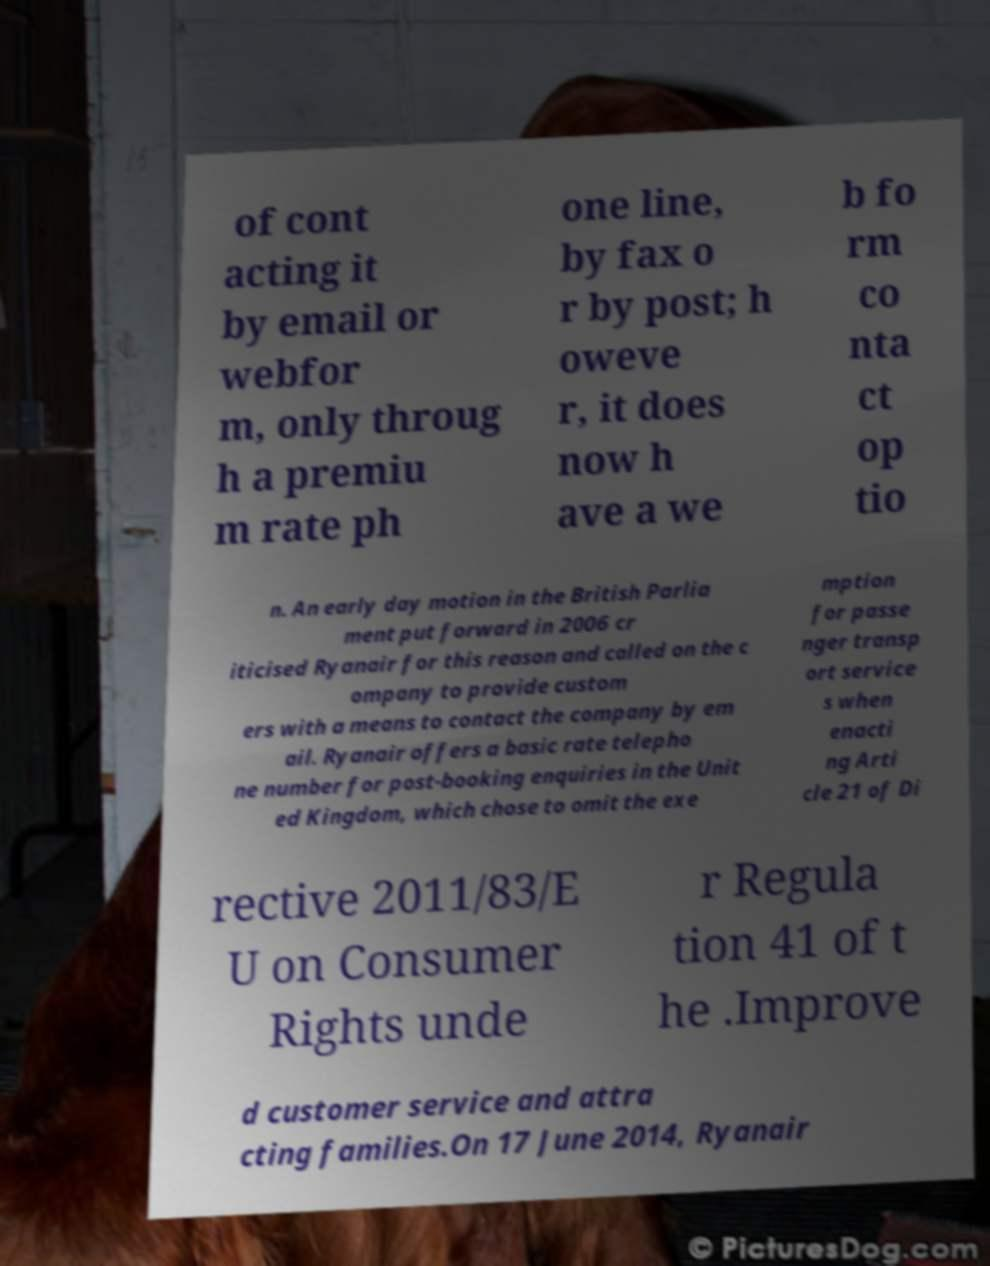There's text embedded in this image that I need extracted. Can you transcribe it verbatim? of cont acting it by email or webfor m, only throug h a premiu m rate ph one line, by fax o r by post; h oweve r, it does now h ave a we b fo rm co nta ct op tio n. An early day motion in the British Parlia ment put forward in 2006 cr iticised Ryanair for this reason and called on the c ompany to provide custom ers with a means to contact the company by em ail. Ryanair offers a basic rate telepho ne number for post-booking enquiries in the Unit ed Kingdom, which chose to omit the exe mption for passe nger transp ort service s when enacti ng Arti cle 21 of Di rective 2011/83/E U on Consumer Rights unde r Regula tion 41 of t he .Improve d customer service and attra cting families.On 17 June 2014, Ryanair 